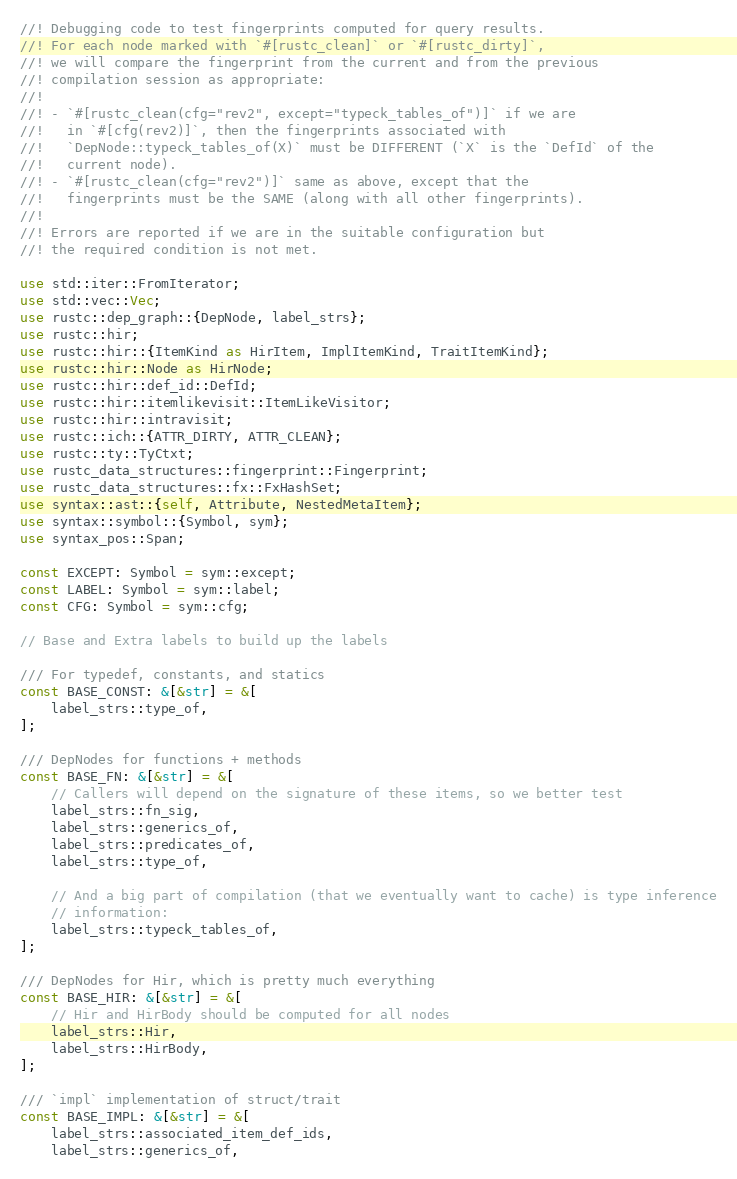<code> <loc_0><loc_0><loc_500><loc_500><_Rust_>//! Debugging code to test fingerprints computed for query results.
//! For each node marked with `#[rustc_clean]` or `#[rustc_dirty]`,
//! we will compare the fingerprint from the current and from the previous
//! compilation session as appropriate:
//!
//! - `#[rustc_clean(cfg="rev2", except="typeck_tables_of")]` if we are
//!   in `#[cfg(rev2)]`, then the fingerprints associated with
//!   `DepNode::typeck_tables_of(X)` must be DIFFERENT (`X` is the `DefId` of the
//!   current node).
//! - `#[rustc_clean(cfg="rev2")]` same as above, except that the
//!   fingerprints must be the SAME (along with all other fingerprints).
//!
//! Errors are reported if we are in the suitable configuration but
//! the required condition is not met.

use std::iter::FromIterator;
use std::vec::Vec;
use rustc::dep_graph::{DepNode, label_strs};
use rustc::hir;
use rustc::hir::{ItemKind as HirItem, ImplItemKind, TraitItemKind};
use rustc::hir::Node as HirNode;
use rustc::hir::def_id::DefId;
use rustc::hir::itemlikevisit::ItemLikeVisitor;
use rustc::hir::intravisit;
use rustc::ich::{ATTR_DIRTY, ATTR_CLEAN};
use rustc::ty::TyCtxt;
use rustc_data_structures::fingerprint::Fingerprint;
use rustc_data_structures::fx::FxHashSet;
use syntax::ast::{self, Attribute, NestedMetaItem};
use syntax::symbol::{Symbol, sym};
use syntax_pos::Span;

const EXCEPT: Symbol = sym::except;
const LABEL: Symbol = sym::label;
const CFG: Symbol = sym::cfg;

// Base and Extra labels to build up the labels

/// For typedef, constants, and statics
const BASE_CONST: &[&str] = &[
    label_strs::type_of,
];

/// DepNodes for functions + methods
const BASE_FN: &[&str] = &[
    // Callers will depend on the signature of these items, so we better test
    label_strs::fn_sig,
    label_strs::generics_of,
    label_strs::predicates_of,
    label_strs::type_of,

    // And a big part of compilation (that we eventually want to cache) is type inference
    // information:
    label_strs::typeck_tables_of,
];

/// DepNodes for Hir, which is pretty much everything
const BASE_HIR: &[&str] = &[
    // Hir and HirBody should be computed for all nodes
    label_strs::Hir,
    label_strs::HirBody,
];

/// `impl` implementation of struct/trait
const BASE_IMPL: &[&str] = &[
    label_strs::associated_item_def_ids,
    label_strs::generics_of,</code> 